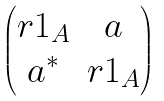<formula> <loc_0><loc_0><loc_500><loc_500>\begin{pmatrix} r 1 _ { A } & a \\ a ^ { * } & r 1 _ { A } \end{pmatrix}</formula> 